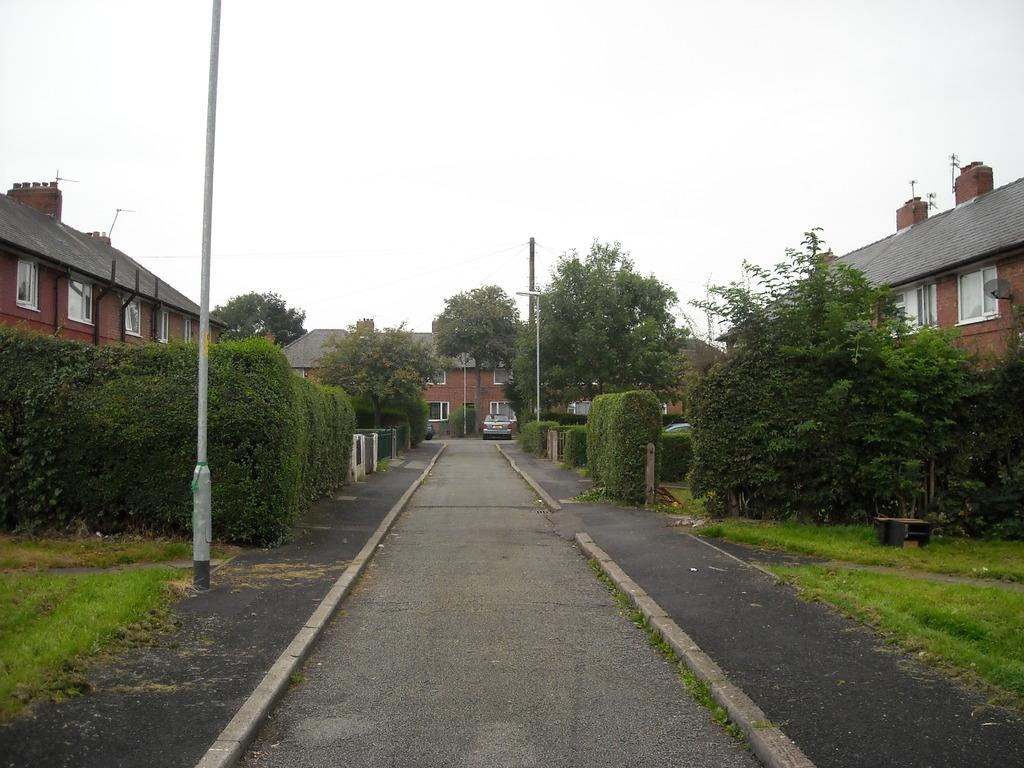What type of vegetation can be seen in the foreground of the image? There is grass, plants, and trees in the foreground of the image. What structures are present in the foreground of the image? There are poles, a fence, and buildings in the foreground of the image. What is on the road in the foreground of the image? There is a vehicle on the road in the foreground of the image. What can be seen in the background of the image? The sky is visible in the background of the image. Can you determine the time of day the image was taken? Yes, the image appears to be taken during the day. How many spiders are crawling on the vehicle in the image? There are no spiders visible in the image, so it is not possible to determine their presence or quantity. Can you describe the kiss between the two people in the image? There are no people or kisses present in the image; it features a vehicle, vegetation, and structures. 